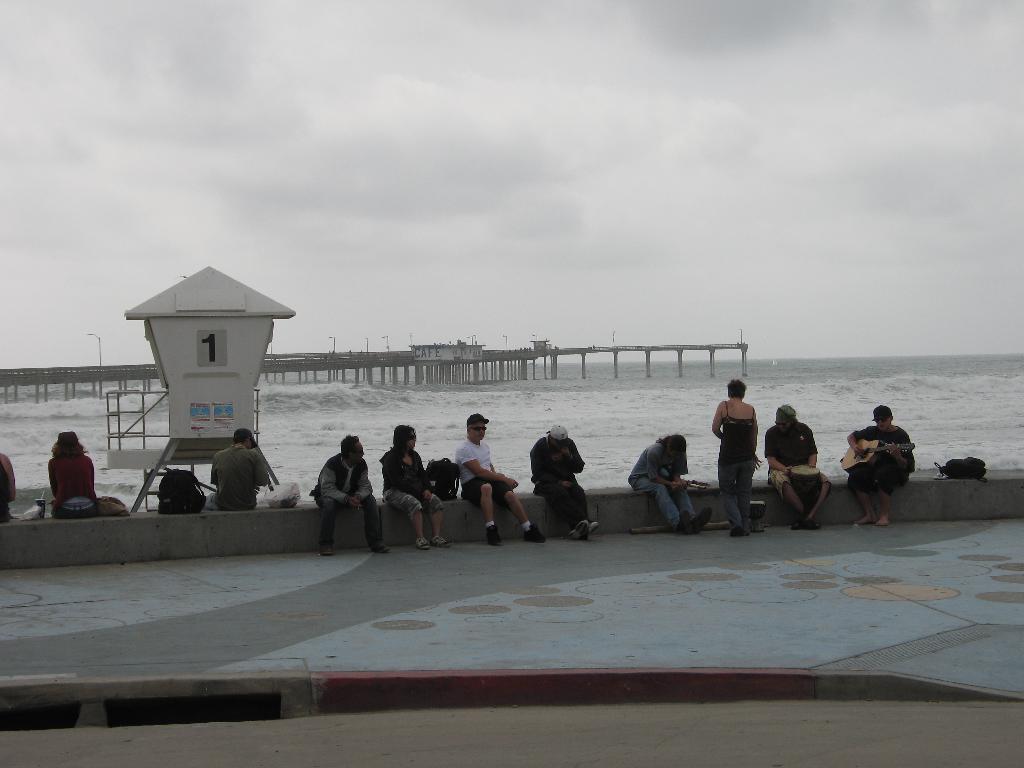Please provide a concise description of this image. In the foreground of this picture, there are people sitting near the sea. In the background, we can see the sea, dock, poles, and the cloud. 